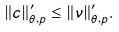Convert formula to latex. <formula><loc_0><loc_0><loc_500><loc_500>\| c \| ^ { \prime } _ { \theta , p } \leq \| \nu \| ^ { \prime } _ { \theta , p } .</formula> 